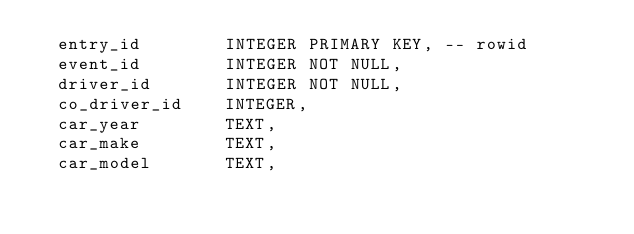Convert code to text. <code><loc_0><loc_0><loc_500><loc_500><_SQL_>  entry_id        INTEGER PRIMARY KEY, -- rowid
  event_id        INTEGER NOT NULL,
  driver_id       INTEGER NOT NULL,
  co_driver_id    INTEGER,
  car_year        TEXT,
  car_make        TEXT,
  car_model       TEXT,</code> 